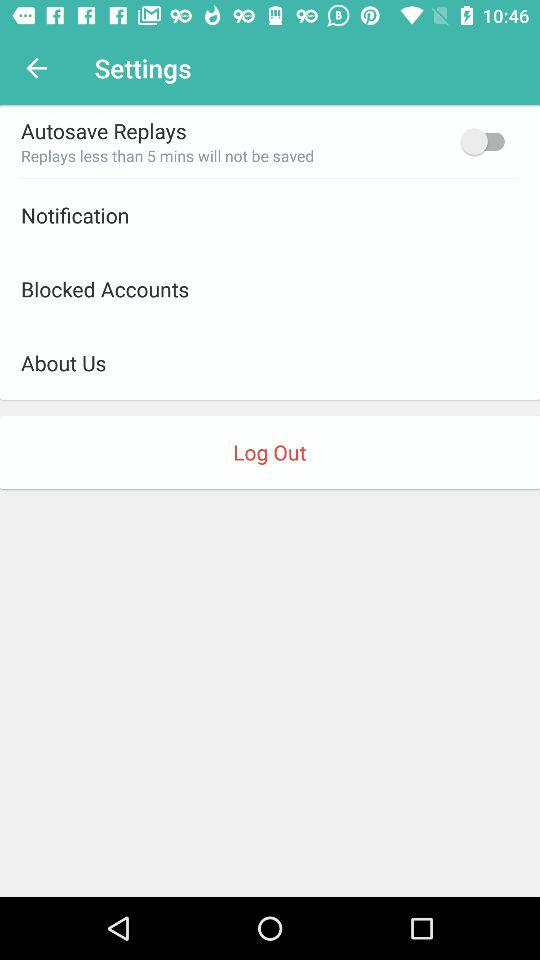How many items are in the settings menu that have a switch?
Answer the question using a single word or phrase. 1 